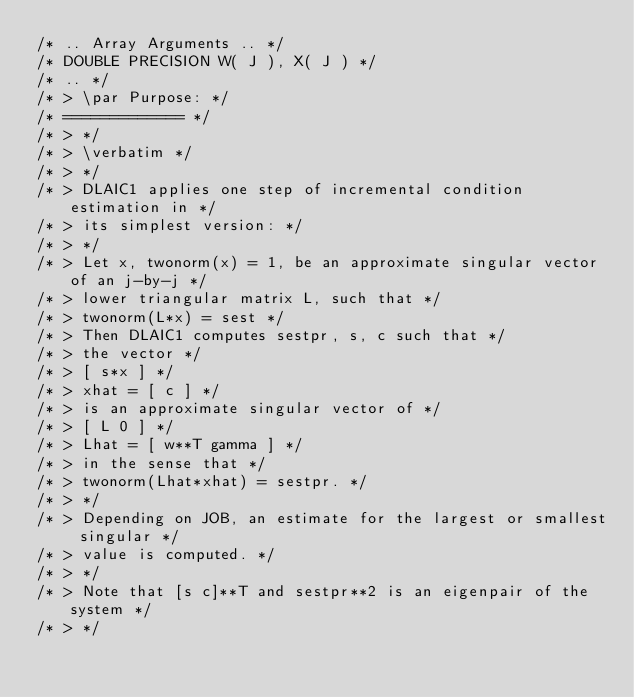<code> <loc_0><loc_0><loc_500><loc_500><_C_>/* .. Array Arguments .. */
/* DOUBLE PRECISION W( J ), X( J ) */
/* .. */
/* > \par Purpose: */
/* ============= */
/* > */
/* > \verbatim */
/* > */
/* > DLAIC1 applies one step of incremental condition estimation in */
/* > its simplest version: */
/* > */
/* > Let x, twonorm(x) = 1, be an approximate singular vector of an j-by-j */
/* > lower triangular matrix L, such that */
/* > twonorm(L*x) = sest */
/* > Then DLAIC1 computes sestpr, s, c such that */
/* > the vector */
/* > [ s*x ] */
/* > xhat = [ c ] */
/* > is an approximate singular vector of */
/* > [ L 0 ] */
/* > Lhat = [ w**T gamma ] */
/* > in the sense that */
/* > twonorm(Lhat*xhat) = sestpr. */
/* > */
/* > Depending on JOB, an estimate for the largest or smallest singular */
/* > value is computed. */
/* > */
/* > Note that [s c]**T and sestpr**2 is an eigenpair of the system */
/* > */</code> 